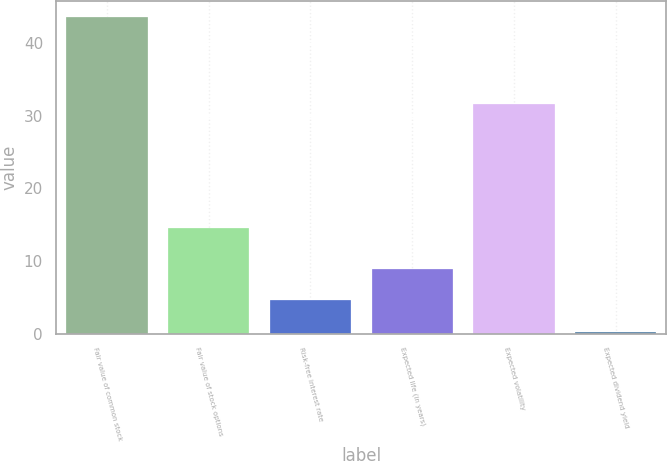<chart> <loc_0><loc_0><loc_500><loc_500><bar_chart><fcel>Fair value of common stock<fcel>Fair value of stock options<fcel>Risk-free interest rate<fcel>Expected life (in years)<fcel>Expected volatility<fcel>Expected dividend yield<nl><fcel>43.6<fcel>14.5<fcel>4.59<fcel>8.92<fcel>31.6<fcel>0.26<nl></chart> 